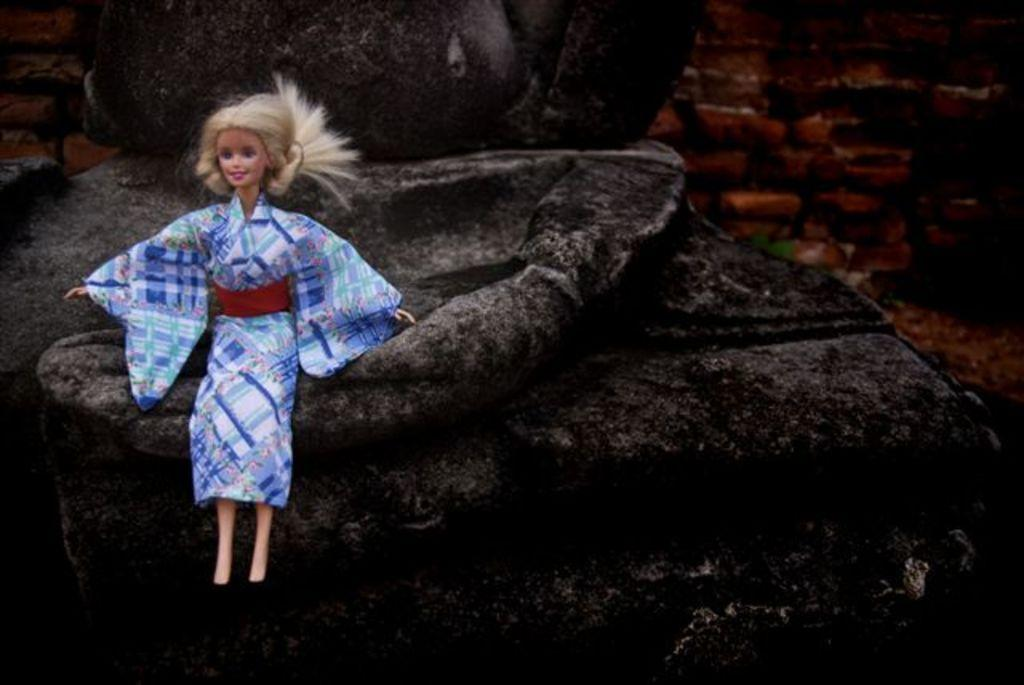What object can be seen in the image? There is a toy in the image. What can be seen behind the toy? There is a wall visible in the background of the image. What type of insect is crawling on the toy in the image? There is no insect present in the image; it only features a toy and a wall in the background. 